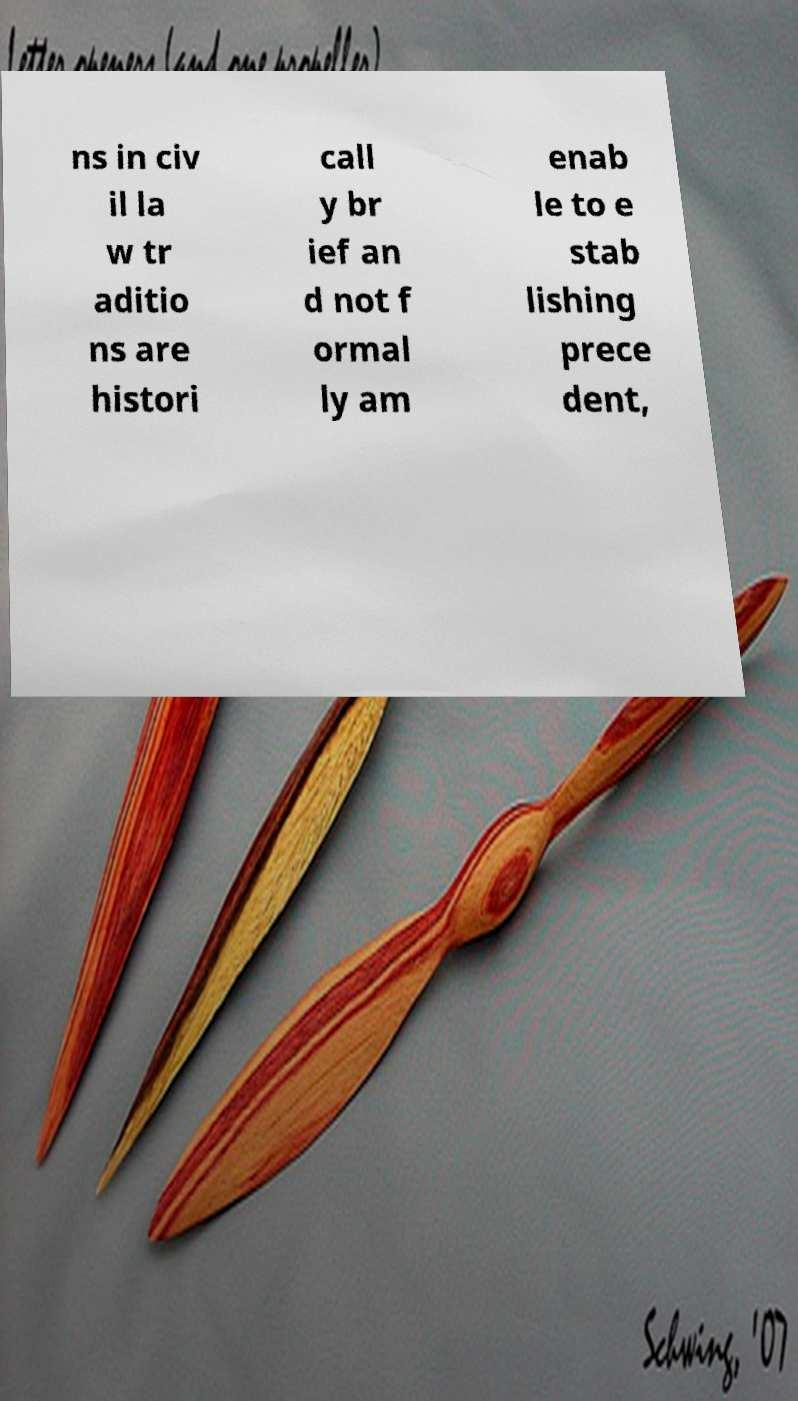Please read and relay the text visible in this image. What does it say? ns in civ il la w tr aditio ns are histori call y br ief an d not f ormal ly am enab le to e stab lishing prece dent, 